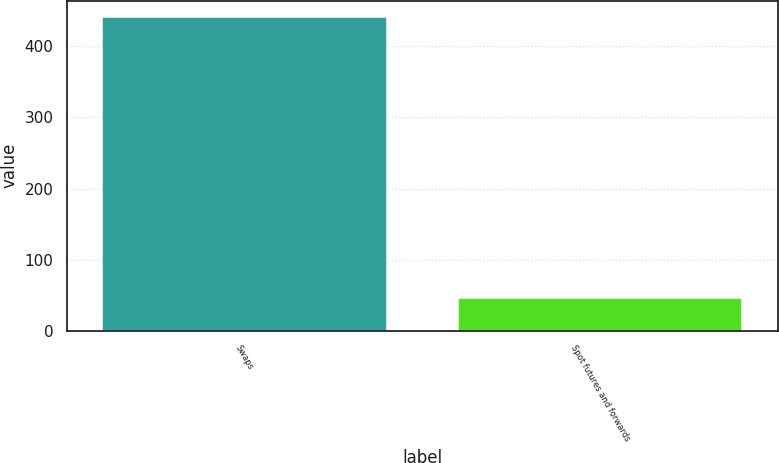Convert chart. <chart><loc_0><loc_0><loc_500><loc_500><bar_chart><fcel>Swaps<fcel>Spot futures and forwards<nl><fcel>442<fcel>46.1<nl></chart> 